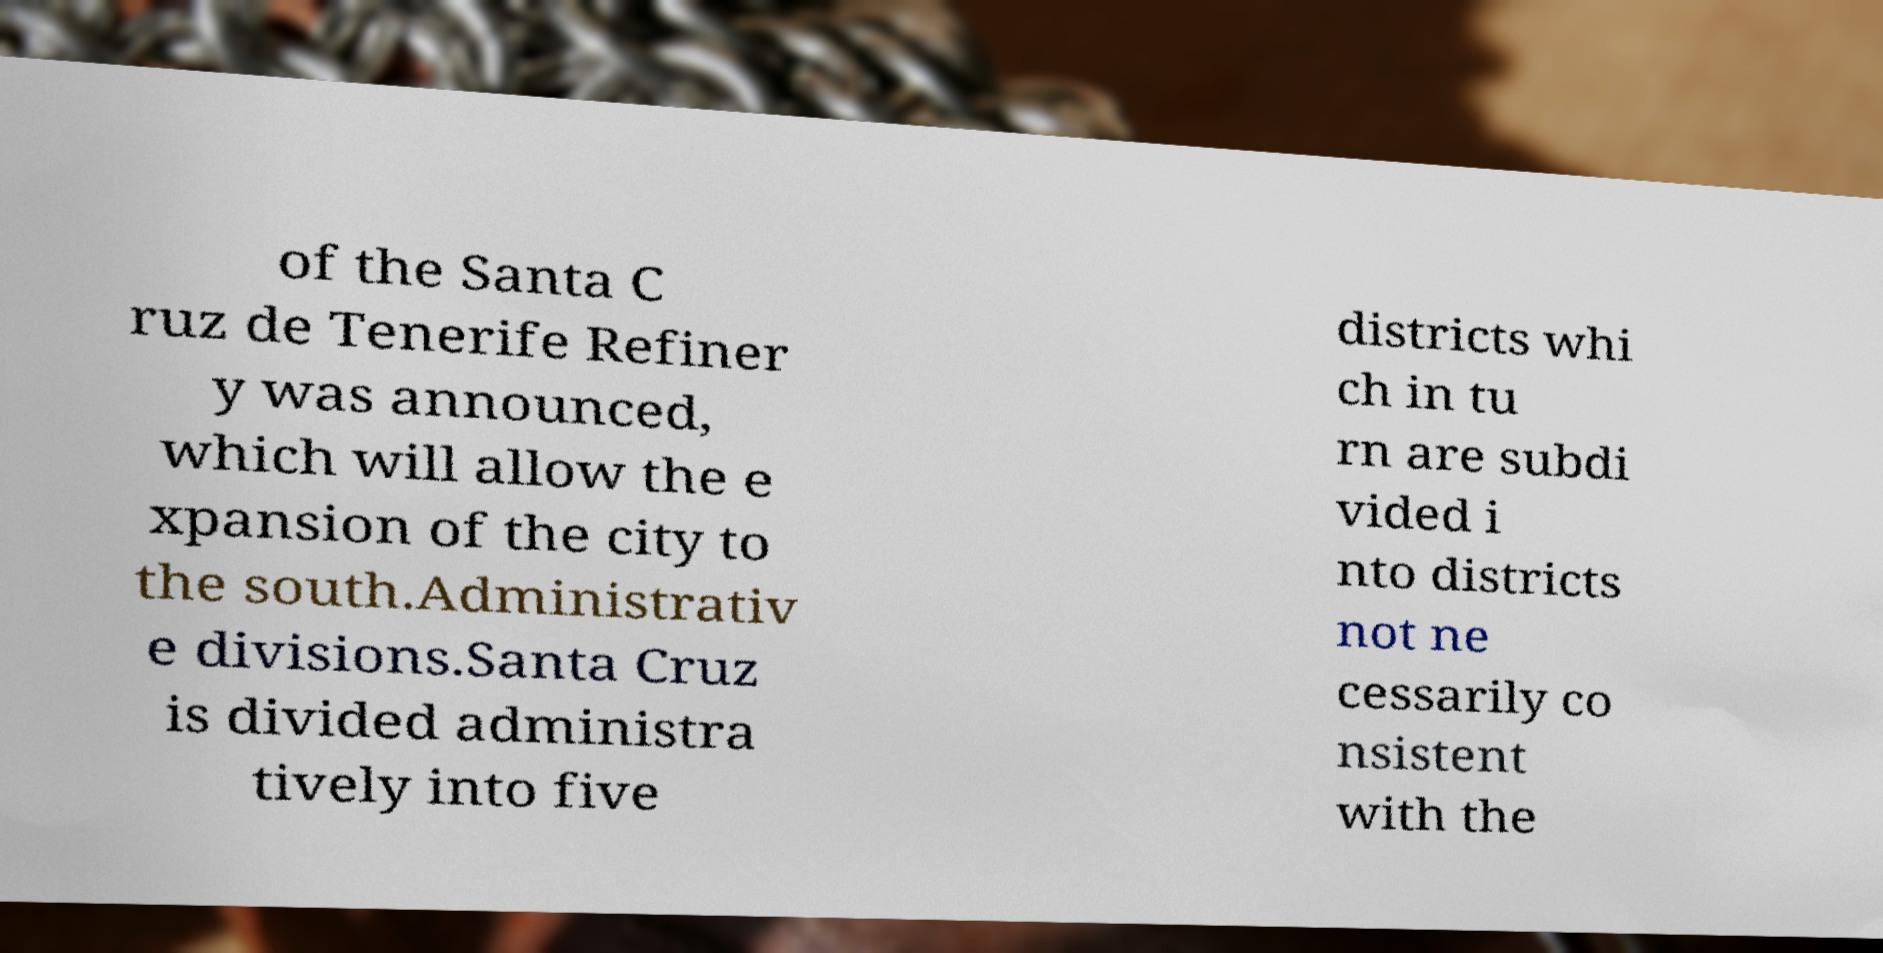What messages or text are displayed in this image? I need them in a readable, typed format. of the Santa C ruz de Tenerife Refiner y was announced, which will allow the e xpansion of the city to the south.Administrativ e divisions.Santa Cruz is divided administra tively into five districts whi ch in tu rn are subdi vided i nto districts not ne cessarily co nsistent with the 